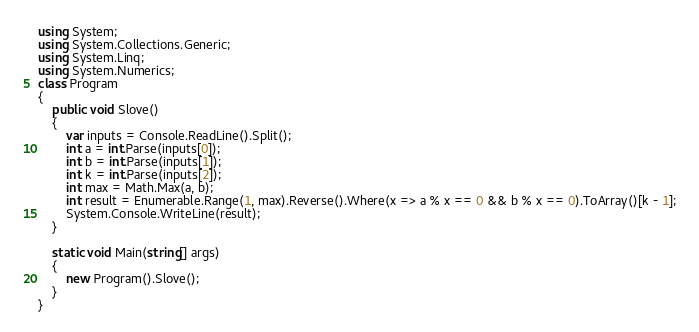Convert code to text. <code><loc_0><loc_0><loc_500><loc_500><_C#_>using System;
using System.Collections.Generic;
using System.Linq;
using System.Numerics;
class Program
{       
    public void Slove()
    {
        var inputs = Console.ReadLine().Split();
        int a = int.Parse(inputs[0]);
        int b = int.Parse(inputs[1]);
        int k = int.Parse(inputs[2]);
        int max = Math.Max(a, b);
        int result = Enumerable.Range(1, max).Reverse().Where(x => a % x == 0 && b % x == 0).ToArray()[k - 1];
        System.Console.WriteLine(result);
    }
    
    static void Main(string[] args)
    {
        new Program().Slove();
    }
}
</code> 